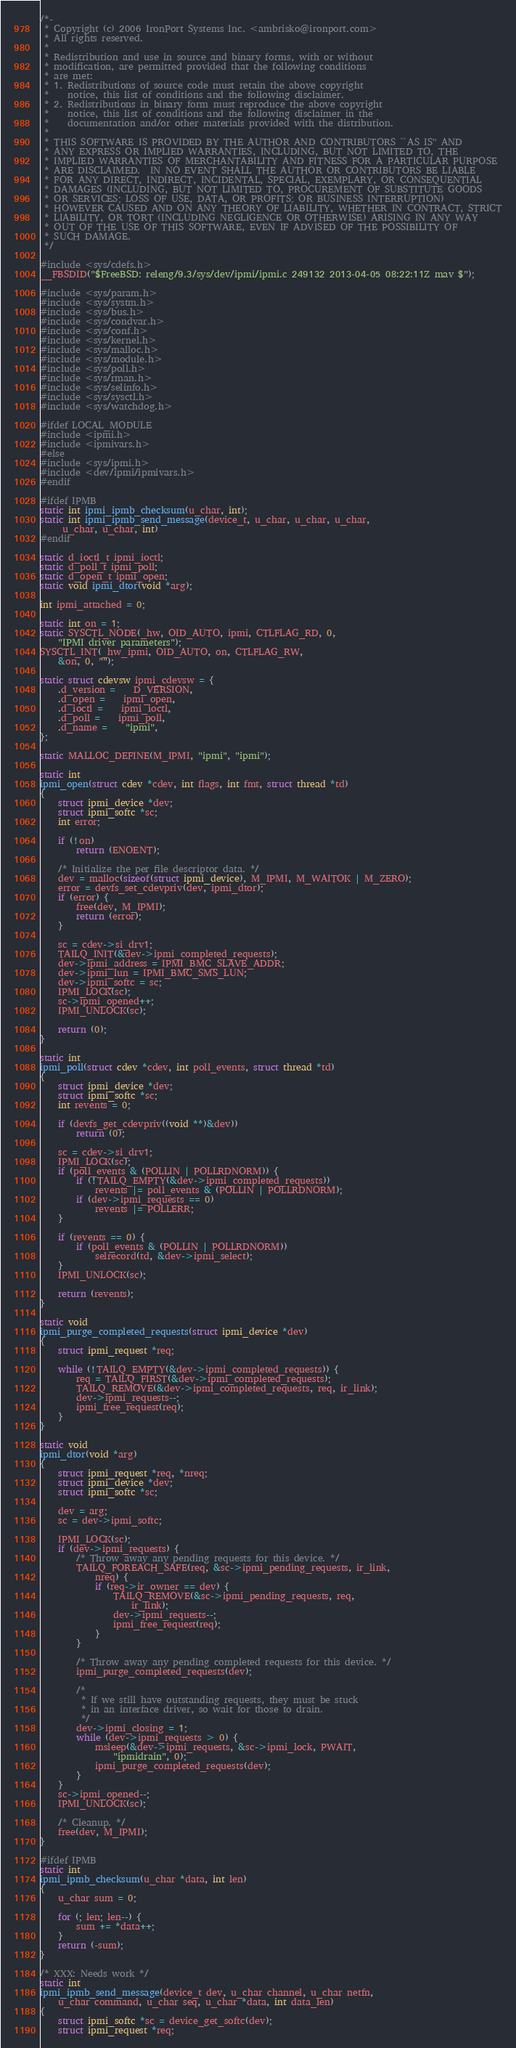<code> <loc_0><loc_0><loc_500><loc_500><_C_>/*-
 * Copyright (c) 2006 IronPort Systems Inc. <ambrisko@ironport.com>
 * All rights reserved.
 *
 * Redistribution and use in source and binary forms, with or without
 * modification, are permitted provided that the following conditions
 * are met:
 * 1. Redistributions of source code must retain the above copyright
 *    notice, this list of conditions and the following disclaimer.
 * 2. Redistributions in binary form must reproduce the above copyright
 *    notice, this list of conditions and the following disclaimer in the
 *    documentation and/or other materials provided with the distribution.
 *
 * THIS SOFTWARE IS PROVIDED BY THE AUTHOR AND CONTRIBUTORS ``AS IS'' AND
 * ANY EXPRESS OR IMPLIED WARRANTIES, INCLUDING, BUT NOT LIMITED TO, THE
 * IMPLIED WARRANTIES OF MERCHANTABILITY AND FITNESS FOR A PARTICULAR PURPOSE
 * ARE DISCLAIMED.  IN NO EVENT SHALL THE AUTHOR OR CONTRIBUTORS BE LIABLE
 * FOR ANY DIRECT, INDIRECT, INCIDENTAL, SPECIAL, EXEMPLARY, OR CONSEQUENTIAL
 * DAMAGES (INCLUDING, BUT NOT LIMITED TO, PROCUREMENT OF SUBSTITUTE GOODS
 * OR SERVICES; LOSS OF USE, DATA, OR PROFITS; OR BUSINESS INTERRUPTION)
 * HOWEVER CAUSED AND ON ANY THEORY OF LIABILITY, WHETHER IN CONTRACT, STRICT
 * LIABILITY, OR TORT (INCLUDING NEGLIGENCE OR OTHERWISE) ARISING IN ANY WAY
 * OUT OF THE USE OF THIS SOFTWARE, EVEN IF ADVISED OF THE POSSIBILITY OF
 * SUCH DAMAGE.
 */

#include <sys/cdefs.h>
__FBSDID("$FreeBSD: releng/9.3/sys/dev/ipmi/ipmi.c 249132 2013-04-05 08:22:11Z mav $");

#include <sys/param.h>
#include <sys/systm.h>
#include <sys/bus.h>
#include <sys/condvar.h>
#include <sys/conf.h>
#include <sys/kernel.h>
#include <sys/malloc.h>
#include <sys/module.h>
#include <sys/poll.h>
#include <sys/rman.h>
#include <sys/selinfo.h>
#include <sys/sysctl.h>
#include <sys/watchdog.h>

#ifdef LOCAL_MODULE
#include <ipmi.h>
#include <ipmivars.h>
#else
#include <sys/ipmi.h>
#include <dev/ipmi/ipmivars.h>
#endif

#ifdef IPMB
static int ipmi_ipmb_checksum(u_char, int);
static int ipmi_ipmb_send_message(device_t, u_char, u_char, u_char,
     u_char, u_char, int)
#endif

static d_ioctl_t ipmi_ioctl;
static d_poll_t ipmi_poll;
static d_open_t ipmi_open;
static void ipmi_dtor(void *arg);

int ipmi_attached = 0;

static int on = 1;
static SYSCTL_NODE(_hw, OID_AUTO, ipmi, CTLFLAG_RD, 0,
    "IPMI driver parameters");
SYSCTL_INT(_hw_ipmi, OID_AUTO, on, CTLFLAG_RW,
	&on, 0, "");

static struct cdevsw ipmi_cdevsw = {
	.d_version =    D_VERSION,
	.d_open =	ipmi_open,
	.d_ioctl =	ipmi_ioctl,
	.d_poll =	ipmi_poll,
	.d_name =	"ipmi",
};

static MALLOC_DEFINE(M_IPMI, "ipmi", "ipmi");

static int
ipmi_open(struct cdev *cdev, int flags, int fmt, struct thread *td)
{
	struct ipmi_device *dev;
	struct ipmi_softc *sc;
	int error;

	if (!on)
		return (ENOENT);

	/* Initialize the per file descriptor data. */
	dev = malloc(sizeof(struct ipmi_device), M_IPMI, M_WAITOK | M_ZERO);
	error = devfs_set_cdevpriv(dev, ipmi_dtor);
	if (error) {
		free(dev, M_IPMI);
		return (error);
	}

	sc = cdev->si_drv1;
	TAILQ_INIT(&dev->ipmi_completed_requests);
	dev->ipmi_address = IPMI_BMC_SLAVE_ADDR;
	dev->ipmi_lun = IPMI_BMC_SMS_LUN;
	dev->ipmi_softc = sc;
	IPMI_LOCK(sc);
	sc->ipmi_opened++;
	IPMI_UNLOCK(sc);

	return (0);
}

static int
ipmi_poll(struct cdev *cdev, int poll_events, struct thread *td)
{
	struct ipmi_device *dev;
	struct ipmi_softc *sc;
	int revents = 0;

	if (devfs_get_cdevpriv((void **)&dev))
		return (0);

	sc = cdev->si_drv1;
	IPMI_LOCK(sc);
	if (poll_events & (POLLIN | POLLRDNORM)) {
		if (!TAILQ_EMPTY(&dev->ipmi_completed_requests))
		    revents |= poll_events & (POLLIN | POLLRDNORM);
		if (dev->ipmi_requests == 0)
		    revents |= POLLERR;
	}

	if (revents == 0) {
		if (poll_events & (POLLIN | POLLRDNORM))
			selrecord(td, &dev->ipmi_select);
	}
	IPMI_UNLOCK(sc);

	return (revents);
}

static void
ipmi_purge_completed_requests(struct ipmi_device *dev)
{
	struct ipmi_request *req;

	while (!TAILQ_EMPTY(&dev->ipmi_completed_requests)) {
		req = TAILQ_FIRST(&dev->ipmi_completed_requests);
		TAILQ_REMOVE(&dev->ipmi_completed_requests, req, ir_link);
		dev->ipmi_requests--;
		ipmi_free_request(req);
	}
}

static void
ipmi_dtor(void *arg)
{
	struct ipmi_request *req, *nreq;
	struct ipmi_device *dev;
	struct ipmi_softc *sc;

	dev = arg;
	sc = dev->ipmi_softc;

	IPMI_LOCK(sc);
	if (dev->ipmi_requests) {
		/* Throw away any pending requests for this device. */
		TAILQ_FOREACH_SAFE(req, &sc->ipmi_pending_requests, ir_link,
		    nreq) {
			if (req->ir_owner == dev) {
				TAILQ_REMOVE(&sc->ipmi_pending_requests, req,
				    ir_link);
				dev->ipmi_requests--;
				ipmi_free_request(req);
			}
		}

		/* Throw away any pending completed requests for this device. */
		ipmi_purge_completed_requests(dev);

		/*
		 * If we still have outstanding requests, they must be stuck
		 * in an interface driver, so wait for those to drain.
		 */
		dev->ipmi_closing = 1;
		while (dev->ipmi_requests > 0) {
			msleep(&dev->ipmi_requests, &sc->ipmi_lock, PWAIT,
			    "ipmidrain", 0);
			ipmi_purge_completed_requests(dev);
		}
	}
	sc->ipmi_opened--;
	IPMI_UNLOCK(sc);

	/* Cleanup. */
	free(dev, M_IPMI);
}

#ifdef IPMB
static int
ipmi_ipmb_checksum(u_char *data, int len)
{
	u_char sum = 0;

	for (; len; len--) {
		sum += *data++;
	}
	return (-sum);
}

/* XXX: Needs work */
static int
ipmi_ipmb_send_message(device_t dev, u_char channel, u_char netfn,
    u_char command, u_char seq, u_char *data, int data_len)
{
	struct ipmi_softc *sc = device_get_softc(dev);
	struct ipmi_request *req;</code> 